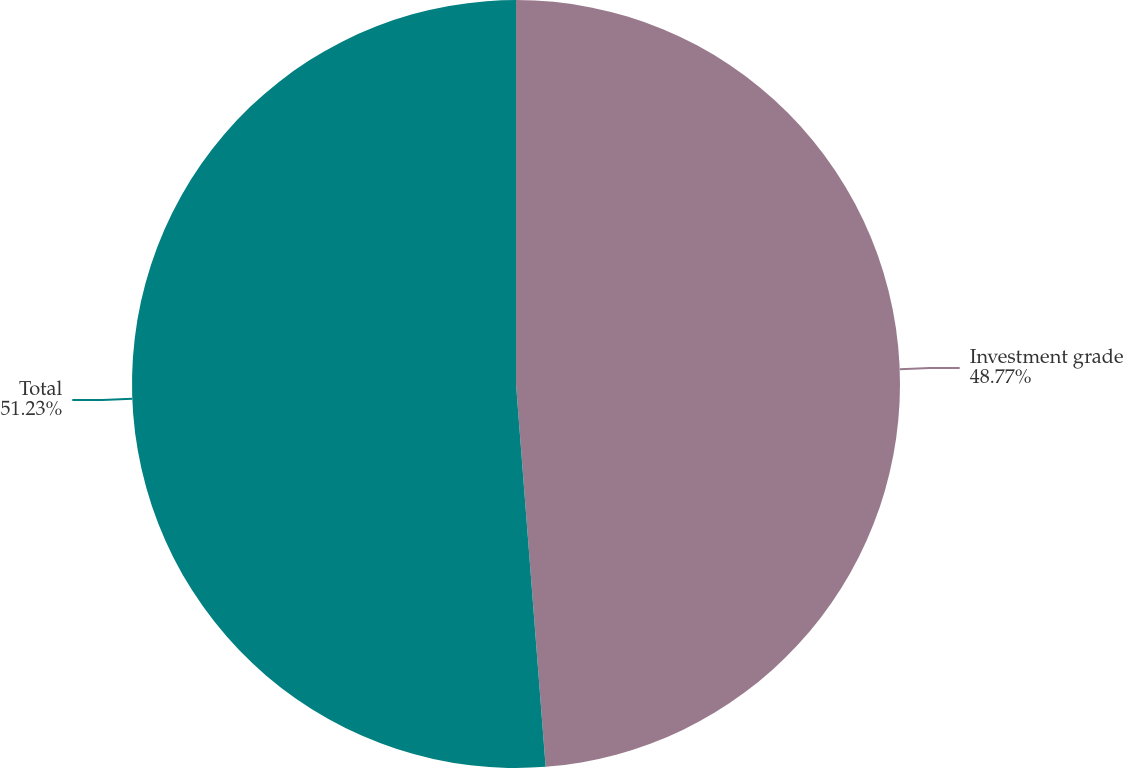Convert chart. <chart><loc_0><loc_0><loc_500><loc_500><pie_chart><fcel>Investment grade<fcel>Total<nl><fcel>48.77%<fcel>51.23%<nl></chart> 